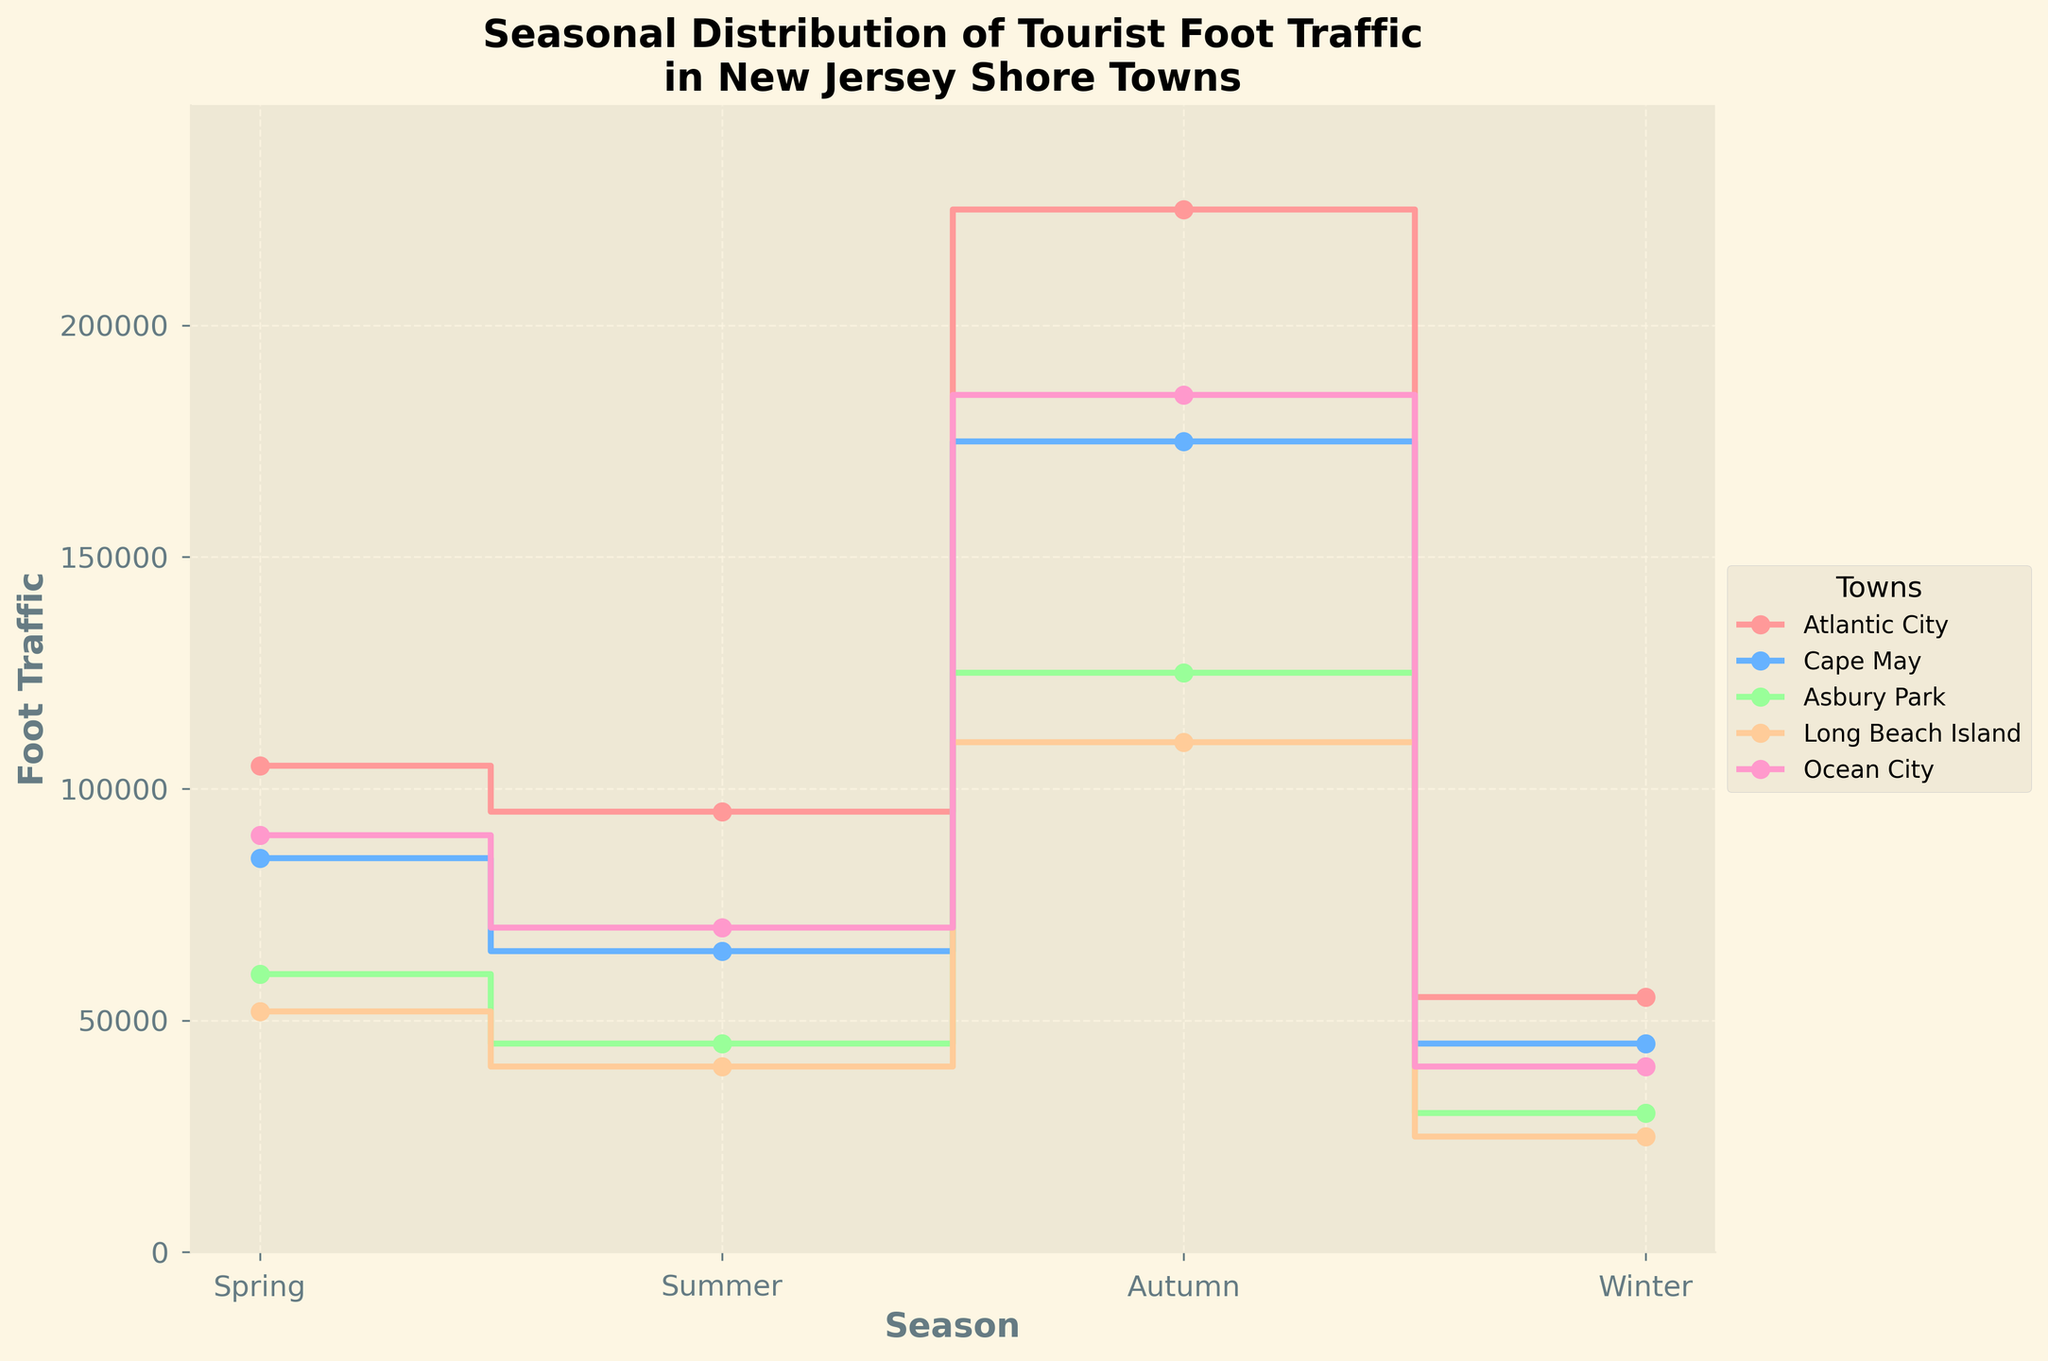what is the town with the highest tourist foot traffic in Summer? To find the town with the highest tourist foot traffic in Summer, observe the plot and identify the town whose curve is at the peak during the Summer season. Atlantic City has the highest value during Summer.
Answer: Atlantic City What is the average tourist foot traffic for Cape May across all seasons? Sum the foot traffic values for Cape May in all seasons and divide by the number of seasons. (65,000 + 175,000 + 85,000 + 45,000) / 4 = 92,500
Answer: 92,500 Which town has the lowest tourist foot traffic in Winter? Identify the town whose curve is at the lowest point during the Winter season. Long Beach Island has the lowest value during Winter.
Answer: Long Beach Island During which season does Ocean City see the least tourist foot traffic? Find the lowest point on the curve for Ocean City across all seasons. Ocean City's lowest point is in Winter.
Answer: Winter What is the difference in tourist foot traffic between Spring and Autumn for Asbury Park? Subtract the foot traffic value in Spring for Asbury Park from the value in Autumn. 60,000 - 45,000 = 15,000
Answer: 15,000 Compare the tourist foot traffic in Summer between Atlantic City and Ocean City. Which has more, and by how much? Subtract the Summer foot traffic of Ocean City from that of Atlantic City. 225,000 - 185,000 = 40,000. Atlantic City has more.
Answer: Atlantic City, 40,000 Which season shows the greatest overall tourist foot traffic among all towns? Observing all towns' curves, identify the season where the values cumulatively peak the most across the towns. Summer has the highest cumulative foot traffic.
Answer: Summer Is there any town that has consistent tourist foot traffic across all seasons? Check if any town's curve shows minimal variation across all seasons. No town has consistent values; all show variation.
Answer: No Which town sees the highest increase in tourist foot traffic from Spring to Summer? Determine the difference between Spring and Summer foot traffic for each town and identify the town with the largest difference. Atlantic City has the highest increase (225,000 - 95,000 = 130,000).
Answer: Atlantic City 